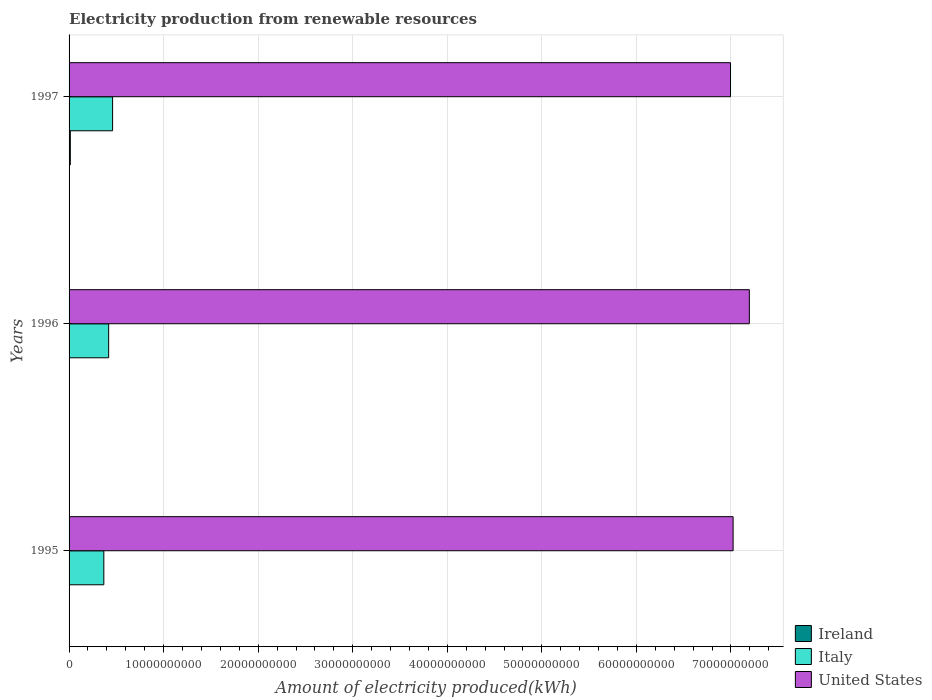How many different coloured bars are there?
Provide a short and direct response. 3. How many groups of bars are there?
Offer a terse response. 3. How many bars are there on the 2nd tick from the top?
Provide a short and direct response. 3. How many bars are there on the 3rd tick from the bottom?
Provide a succinct answer. 3. What is the amount of electricity produced in United States in 1997?
Your response must be concise. 7.00e+1. Across all years, what is the maximum amount of electricity produced in Ireland?
Ensure brevity in your answer.  1.31e+08. Across all years, what is the minimum amount of electricity produced in United States?
Offer a very short reply. 7.00e+1. In which year was the amount of electricity produced in United States minimum?
Provide a succinct answer. 1997. What is the total amount of electricity produced in United States in the graph?
Offer a terse response. 2.12e+11. What is the difference between the amount of electricity produced in Italy in 1995 and that in 1996?
Keep it short and to the point. -5.10e+08. What is the difference between the amount of electricity produced in Italy in 1997 and the amount of electricity produced in Ireland in 1995?
Your answer should be compact. 4.59e+09. What is the average amount of electricity produced in Ireland per year?
Your answer should be compact. 6.27e+07. In the year 1996, what is the difference between the amount of electricity produced in United States and amount of electricity produced in Ireland?
Make the answer very short. 7.19e+1. In how many years, is the amount of electricity produced in Ireland greater than 40000000000 kWh?
Make the answer very short. 0. What is the ratio of the amount of electricity produced in United States in 1996 to that in 1997?
Offer a very short reply. 1.03. Is the amount of electricity produced in United States in 1996 less than that in 1997?
Your response must be concise. No. Is the difference between the amount of electricity produced in United States in 1995 and 1996 greater than the difference between the amount of electricity produced in Ireland in 1995 and 1996?
Give a very brief answer. No. What is the difference between the highest and the second highest amount of electricity produced in United States?
Your response must be concise. 1.72e+09. What is the difference between the highest and the lowest amount of electricity produced in Ireland?
Offer a terse response. 1.15e+08. What does the 1st bar from the bottom in 1996 represents?
Your answer should be very brief. Ireland. Is it the case that in every year, the sum of the amount of electricity produced in Italy and amount of electricity produced in United States is greater than the amount of electricity produced in Ireland?
Provide a succinct answer. Yes. Are all the bars in the graph horizontal?
Ensure brevity in your answer.  Yes. How many years are there in the graph?
Provide a short and direct response. 3. What is the difference between two consecutive major ticks on the X-axis?
Provide a short and direct response. 1.00e+1. How many legend labels are there?
Provide a short and direct response. 3. How are the legend labels stacked?
Offer a very short reply. Vertical. What is the title of the graph?
Make the answer very short. Electricity production from renewable resources. Does "Greece" appear as one of the legend labels in the graph?
Keep it short and to the point. No. What is the label or title of the X-axis?
Ensure brevity in your answer.  Amount of electricity produced(kWh). What is the Amount of electricity produced(kWh) of Ireland in 1995?
Ensure brevity in your answer.  1.60e+07. What is the Amount of electricity produced(kWh) of Italy in 1995?
Provide a succinct answer. 3.68e+09. What is the Amount of electricity produced(kWh) of United States in 1995?
Offer a very short reply. 7.02e+1. What is the Amount of electricity produced(kWh) of Ireland in 1996?
Keep it short and to the point. 4.10e+07. What is the Amount of electricity produced(kWh) of Italy in 1996?
Your response must be concise. 4.19e+09. What is the Amount of electricity produced(kWh) of United States in 1996?
Your answer should be compact. 7.19e+1. What is the Amount of electricity produced(kWh) of Ireland in 1997?
Offer a very short reply. 1.31e+08. What is the Amount of electricity produced(kWh) of Italy in 1997?
Your response must be concise. 4.60e+09. What is the Amount of electricity produced(kWh) of United States in 1997?
Offer a terse response. 7.00e+1. Across all years, what is the maximum Amount of electricity produced(kWh) of Ireland?
Offer a very short reply. 1.31e+08. Across all years, what is the maximum Amount of electricity produced(kWh) of Italy?
Provide a short and direct response. 4.60e+09. Across all years, what is the maximum Amount of electricity produced(kWh) of United States?
Offer a very short reply. 7.19e+1. Across all years, what is the minimum Amount of electricity produced(kWh) in Ireland?
Your response must be concise. 1.60e+07. Across all years, what is the minimum Amount of electricity produced(kWh) in Italy?
Your response must be concise. 3.68e+09. Across all years, what is the minimum Amount of electricity produced(kWh) of United States?
Provide a short and direct response. 7.00e+1. What is the total Amount of electricity produced(kWh) of Ireland in the graph?
Your answer should be compact. 1.88e+08. What is the total Amount of electricity produced(kWh) of Italy in the graph?
Keep it short and to the point. 1.25e+1. What is the total Amount of electricity produced(kWh) in United States in the graph?
Offer a terse response. 2.12e+11. What is the difference between the Amount of electricity produced(kWh) in Ireland in 1995 and that in 1996?
Give a very brief answer. -2.50e+07. What is the difference between the Amount of electricity produced(kWh) in Italy in 1995 and that in 1996?
Your answer should be very brief. -5.10e+08. What is the difference between the Amount of electricity produced(kWh) of United States in 1995 and that in 1996?
Ensure brevity in your answer.  -1.72e+09. What is the difference between the Amount of electricity produced(kWh) of Ireland in 1995 and that in 1997?
Ensure brevity in your answer.  -1.15e+08. What is the difference between the Amount of electricity produced(kWh) in Italy in 1995 and that in 1997?
Offer a very short reply. -9.27e+08. What is the difference between the Amount of electricity produced(kWh) of United States in 1995 and that in 1997?
Provide a succinct answer. 2.74e+08. What is the difference between the Amount of electricity produced(kWh) in Ireland in 1996 and that in 1997?
Keep it short and to the point. -9.00e+07. What is the difference between the Amount of electricity produced(kWh) of Italy in 1996 and that in 1997?
Your answer should be very brief. -4.17e+08. What is the difference between the Amount of electricity produced(kWh) of United States in 1996 and that in 1997?
Your response must be concise. 1.99e+09. What is the difference between the Amount of electricity produced(kWh) of Ireland in 1995 and the Amount of electricity produced(kWh) of Italy in 1996?
Offer a terse response. -4.17e+09. What is the difference between the Amount of electricity produced(kWh) in Ireland in 1995 and the Amount of electricity produced(kWh) in United States in 1996?
Make the answer very short. -7.19e+1. What is the difference between the Amount of electricity produced(kWh) of Italy in 1995 and the Amount of electricity produced(kWh) of United States in 1996?
Offer a very short reply. -6.83e+1. What is the difference between the Amount of electricity produced(kWh) of Ireland in 1995 and the Amount of electricity produced(kWh) of Italy in 1997?
Ensure brevity in your answer.  -4.59e+09. What is the difference between the Amount of electricity produced(kWh) in Ireland in 1995 and the Amount of electricity produced(kWh) in United States in 1997?
Offer a terse response. -6.99e+1. What is the difference between the Amount of electricity produced(kWh) of Italy in 1995 and the Amount of electricity produced(kWh) of United States in 1997?
Ensure brevity in your answer.  -6.63e+1. What is the difference between the Amount of electricity produced(kWh) of Ireland in 1996 and the Amount of electricity produced(kWh) of Italy in 1997?
Your answer should be compact. -4.56e+09. What is the difference between the Amount of electricity produced(kWh) of Ireland in 1996 and the Amount of electricity produced(kWh) of United States in 1997?
Keep it short and to the point. -6.99e+1. What is the difference between the Amount of electricity produced(kWh) in Italy in 1996 and the Amount of electricity produced(kWh) in United States in 1997?
Offer a very short reply. -6.58e+1. What is the average Amount of electricity produced(kWh) of Ireland per year?
Provide a succinct answer. 6.27e+07. What is the average Amount of electricity produced(kWh) of Italy per year?
Your answer should be compact. 4.16e+09. What is the average Amount of electricity produced(kWh) in United States per year?
Your answer should be compact. 7.07e+1. In the year 1995, what is the difference between the Amount of electricity produced(kWh) in Ireland and Amount of electricity produced(kWh) in Italy?
Your answer should be compact. -3.66e+09. In the year 1995, what is the difference between the Amount of electricity produced(kWh) in Ireland and Amount of electricity produced(kWh) in United States?
Your response must be concise. -7.02e+1. In the year 1995, what is the difference between the Amount of electricity produced(kWh) of Italy and Amount of electricity produced(kWh) of United States?
Your answer should be very brief. -6.66e+1. In the year 1996, what is the difference between the Amount of electricity produced(kWh) of Ireland and Amount of electricity produced(kWh) of Italy?
Ensure brevity in your answer.  -4.14e+09. In the year 1996, what is the difference between the Amount of electricity produced(kWh) of Ireland and Amount of electricity produced(kWh) of United States?
Provide a succinct answer. -7.19e+1. In the year 1996, what is the difference between the Amount of electricity produced(kWh) in Italy and Amount of electricity produced(kWh) in United States?
Give a very brief answer. -6.78e+1. In the year 1997, what is the difference between the Amount of electricity produced(kWh) of Ireland and Amount of electricity produced(kWh) of Italy?
Keep it short and to the point. -4.47e+09. In the year 1997, what is the difference between the Amount of electricity produced(kWh) in Ireland and Amount of electricity produced(kWh) in United States?
Give a very brief answer. -6.98e+1. In the year 1997, what is the difference between the Amount of electricity produced(kWh) in Italy and Amount of electricity produced(kWh) in United States?
Keep it short and to the point. -6.54e+1. What is the ratio of the Amount of electricity produced(kWh) in Ireland in 1995 to that in 1996?
Your answer should be very brief. 0.39. What is the ratio of the Amount of electricity produced(kWh) in Italy in 1995 to that in 1996?
Your response must be concise. 0.88. What is the ratio of the Amount of electricity produced(kWh) in United States in 1995 to that in 1996?
Offer a very short reply. 0.98. What is the ratio of the Amount of electricity produced(kWh) of Ireland in 1995 to that in 1997?
Offer a terse response. 0.12. What is the ratio of the Amount of electricity produced(kWh) of Italy in 1995 to that in 1997?
Offer a very short reply. 0.8. What is the ratio of the Amount of electricity produced(kWh) in Ireland in 1996 to that in 1997?
Ensure brevity in your answer.  0.31. What is the ratio of the Amount of electricity produced(kWh) of Italy in 1996 to that in 1997?
Ensure brevity in your answer.  0.91. What is the ratio of the Amount of electricity produced(kWh) in United States in 1996 to that in 1997?
Keep it short and to the point. 1.03. What is the difference between the highest and the second highest Amount of electricity produced(kWh) of Ireland?
Make the answer very short. 9.00e+07. What is the difference between the highest and the second highest Amount of electricity produced(kWh) in Italy?
Provide a succinct answer. 4.17e+08. What is the difference between the highest and the second highest Amount of electricity produced(kWh) in United States?
Keep it short and to the point. 1.72e+09. What is the difference between the highest and the lowest Amount of electricity produced(kWh) of Ireland?
Your answer should be compact. 1.15e+08. What is the difference between the highest and the lowest Amount of electricity produced(kWh) in Italy?
Your response must be concise. 9.27e+08. What is the difference between the highest and the lowest Amount of electricity produced(kWh) of United States?
Offer a terse response. 1.99e+09. 